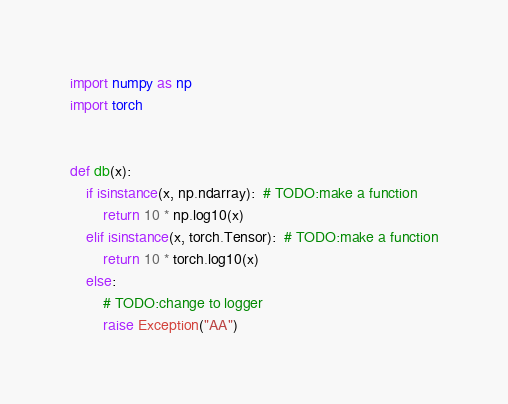Convert code to text. <code><loc_0><loc_0><loc_500><loc_500><_Python_>import numpy as np
import torch


def db(x):
    if isinstance(x, np.ndarray):  # TODO:make a function
        return 10 * np.log10(x)
    elif isinstance(x, torch.Tensor):  # TODO:make a function
        return 10 * torch.log10(x)
    else:
        # TODO:change to logger
        raise Exception("AA")
</code> 